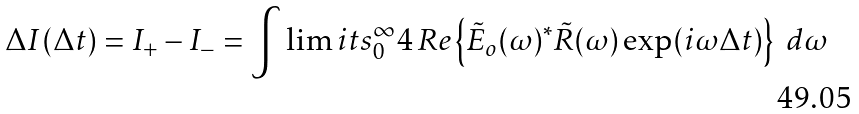Convert formula to latex. <formula><loc_0><loc_0><loc_500><loc_500>\Delta I ( \Delta t ) = I _ { + } - I _ { - } = \int \lim i t s _ { 0 } ^ { \infty } { 4 \, R e \left \{ \tilde { E } _ { o } ( \omega ) ^ { * } \tilde { R } ( \omega ) \exp ( i \omega \Delta t ) \right \} \ d \omega }</formula> 